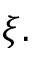<formula> <loc_0><loc_0><loc_500><loc_500>\xi .</formula> 